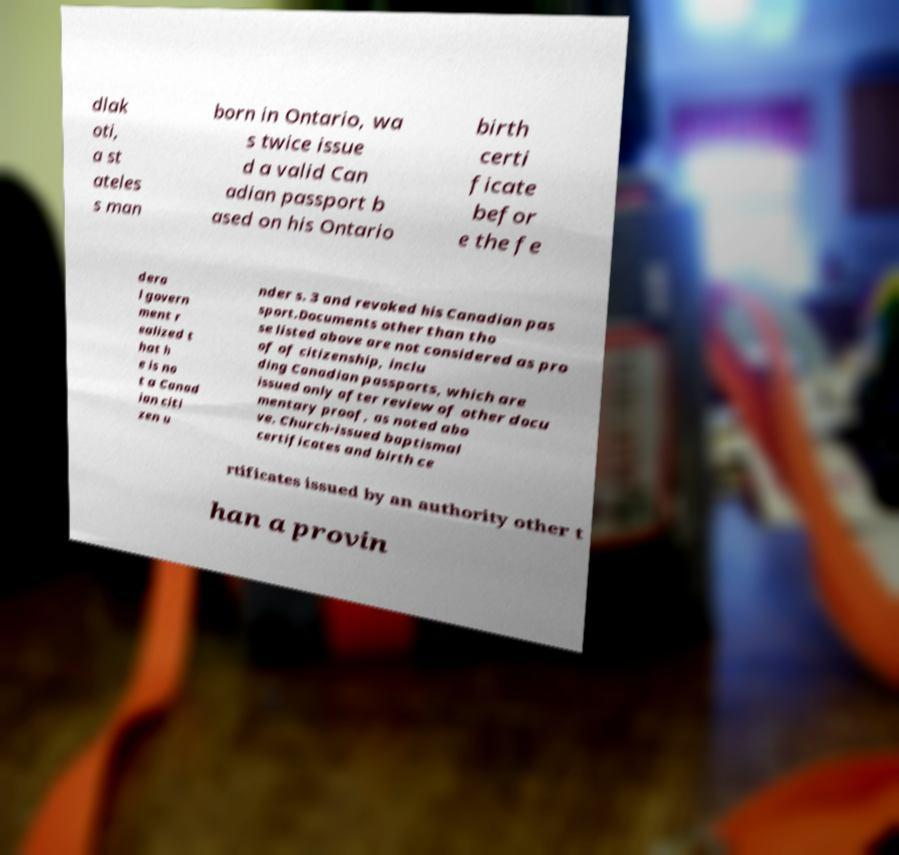Please read and relay the text visible in this image. What does it say? dlak oti, a st ateles s man born in Ontario, wa s twice issue d a valid Can adian passport b ased on his Ontario birth certi ficate befor e the fe dera l govern ment r ealized t hat h e is no t a Canad ian citi zen u nder s. 3 and revoked his Canadian pas sport.Documents other than tho se listed above are not considered as pro of of citizenship, inclu ding Canadian passports, which are issued only after review of other docu mentary proof, as noted abo ve. Church-issued baptismal certificates and birth ce rtificates issued by an authority other t han a provin 